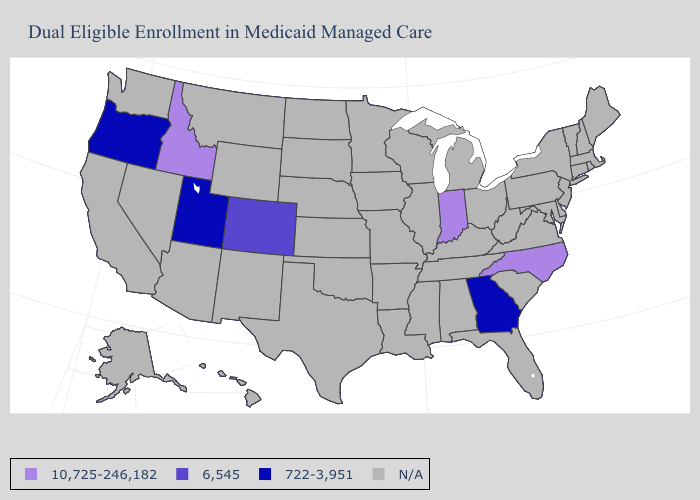Which states hav the highest value in the MidWest?
Quick response, please. Indiana. Name the states that have a value in the range 722-3,951?
Short answer required. Georgia, Oregon, Utah. What is the value of Illinois?
Be succinct. N/A. What is the value of Tennessee?
Keep it brief. N/A. What is the value of Georgia?
Answer briefly. 722-3,951. What is the lowest value in states that border Tennessee?
Short answer required. 722-3,951. Does Idaho have the highest value in the USA?
Keep it brief. Yes. Which states have the lowest value in the USA?
Keep it brief. Georgia, Oregon, Utah. Among the states that border Kentucky , which have the highest value?
Give a very brief answer. Indiana. How many symbols are there in the legend?
Quick response, please. 4. 